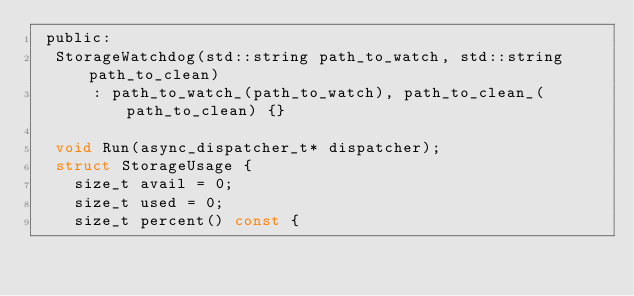<code> <loc_0><loc_0><loc_500><loc_500><_C_> public:
  StorageWatchdog(std::string path_to_watch, std::string path_to_clean)
      : path_to_watch_(path_to_watch), path_to_clean_(path_to_clean) {}

  void Run(async_dispatcher_t* dispatcher);
  struct StorageUsage {
    size_t avail = 0;
    size_t used = 0;
    size_t percent() const {</code> 